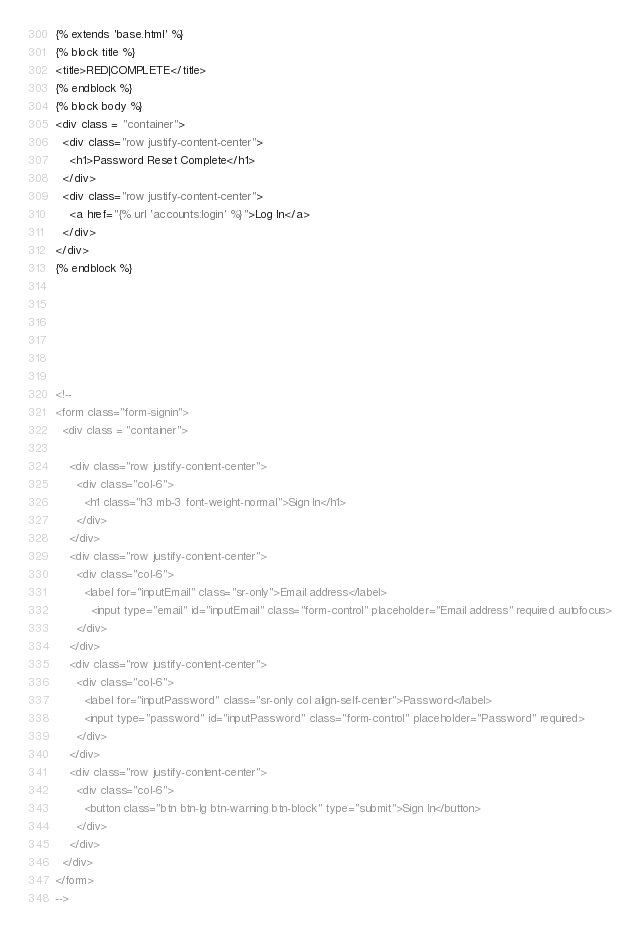<code> <loc_0><loc_0><loc_500><loc_500><_HTML_>{% extends 'base.html' %}
{% block title %}
<title>RED|COMPLETE</title>
{% endblock %}
{% block body %}
<div class = "container">
  <div class="row justify-content-center">
    <h1>Password Reset Complete</h1>
  </div>
  <div class="row justify-content-center">
    <a href="{% url 'accounts:login' %}">Log In</a>
  </div>
</div>
{% endblock %}






<!--
<form class="form-signin">
  <div class = "container">
      
    <div class="row justify-content-center">
      <div class="col-6">
        <h1 class="h3 mb-3 font-weight-normal">Sign In</h1>
      </div>
    </div>
    <div class="row justify-content-center">
      <div class="col-6">
        <label for="inputEmail" class="sr-only">Email address</label>
          <input type="email" id="inputEmail" class="form-control" placeholder="Email address" required autofocus>
      </div>
    </div>
    <div class="row justify-content-center">
      <div class="col-6">
        <label for="inputPassword" class="sr-only col align-self-center">Password</label>
        <input type="password" id="inputPassword" class="form-control" placeholder="Password" required>
      </div>
    </div>
    <div class="row justify-content-center">
      <div class="col-6">
        <button class="btn btn-lg btn-warning btn-block" type="submit">Sign In</button>
      </div>
    </div>
  </div>
</form>
-->
</code> 